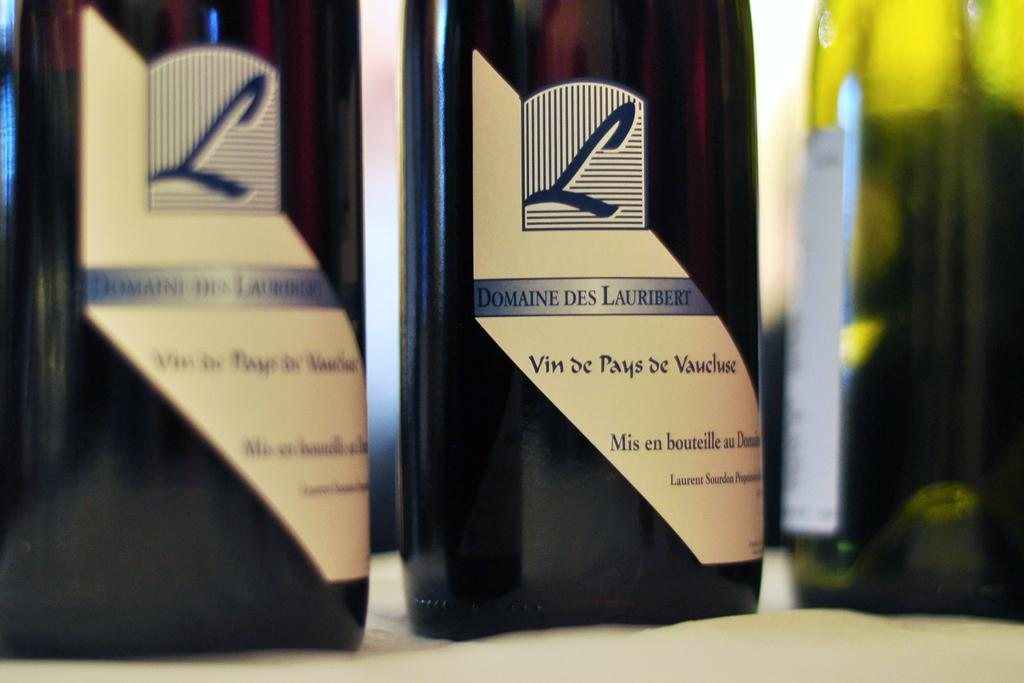<image>
Render a clear and concise summary of the photo. A bottle says Domaine Des Lauribert, Vin de Pays de Vaucluse. 